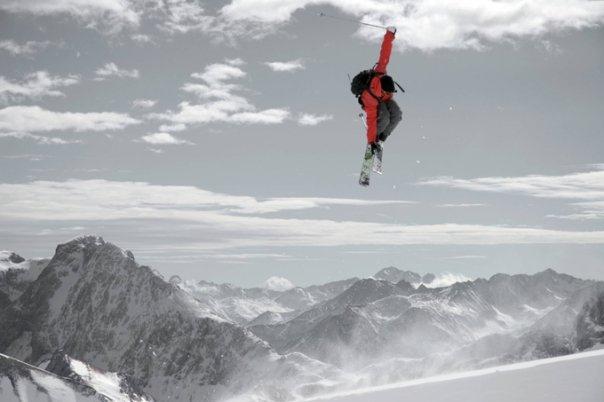What color is the snow?
Answer briefly. White. Is the skier on the ground?
Be succinct. No. What color is his backpack?
Be succinct. Black. What is in the right hand of the skier?
Be succinct. Ski pole. What color is the sky?
Quick response, please. Gray. What can be seen across the hole picture?
Answer briefly. Mountains. 